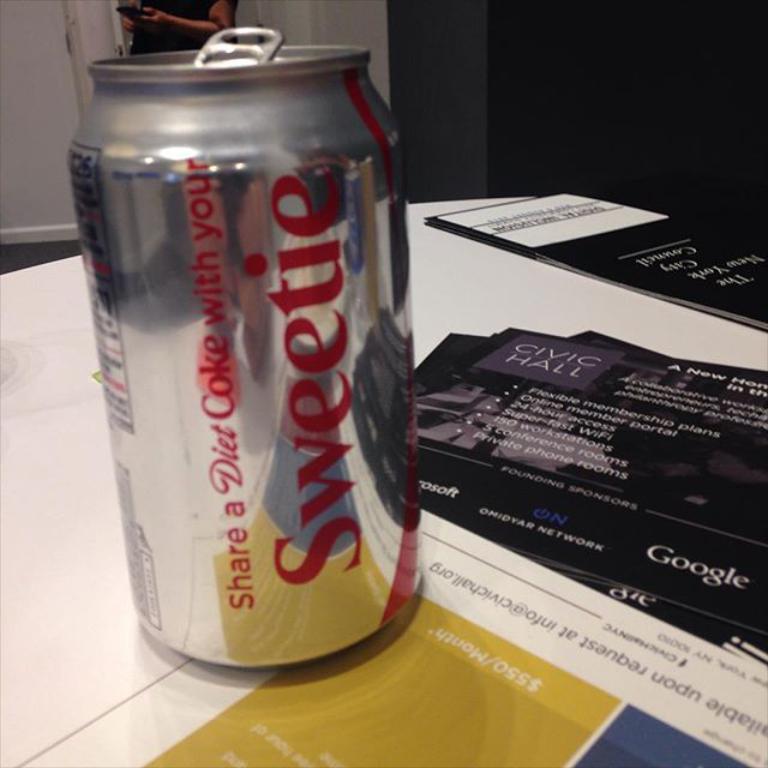What drink is this?
Give a very brief answer. Diet coke. 